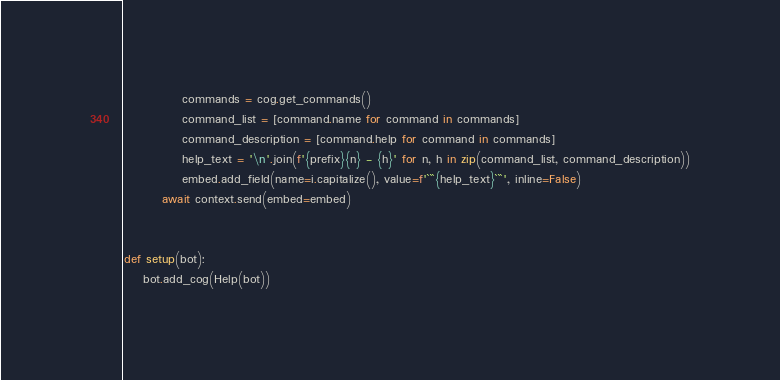<code> <loc_0><loc_0><loc_500><loc_500><_Python_>            commands = cog.get_commands()
            command_list = [command.name for command in commands]
            command_description = [command.help for command in commands]
            help_text = '\n'.join(f'{prefix}{n} - {h}' for n, h in zip(command_list, command_description))
            embed.add_field(name=i.capitalize(), value=f'```{help_text}```', inline=False)
        await context.send(embed=embed)


def setup(bot):
    bot.add_cog(Help(bot))
</code> 